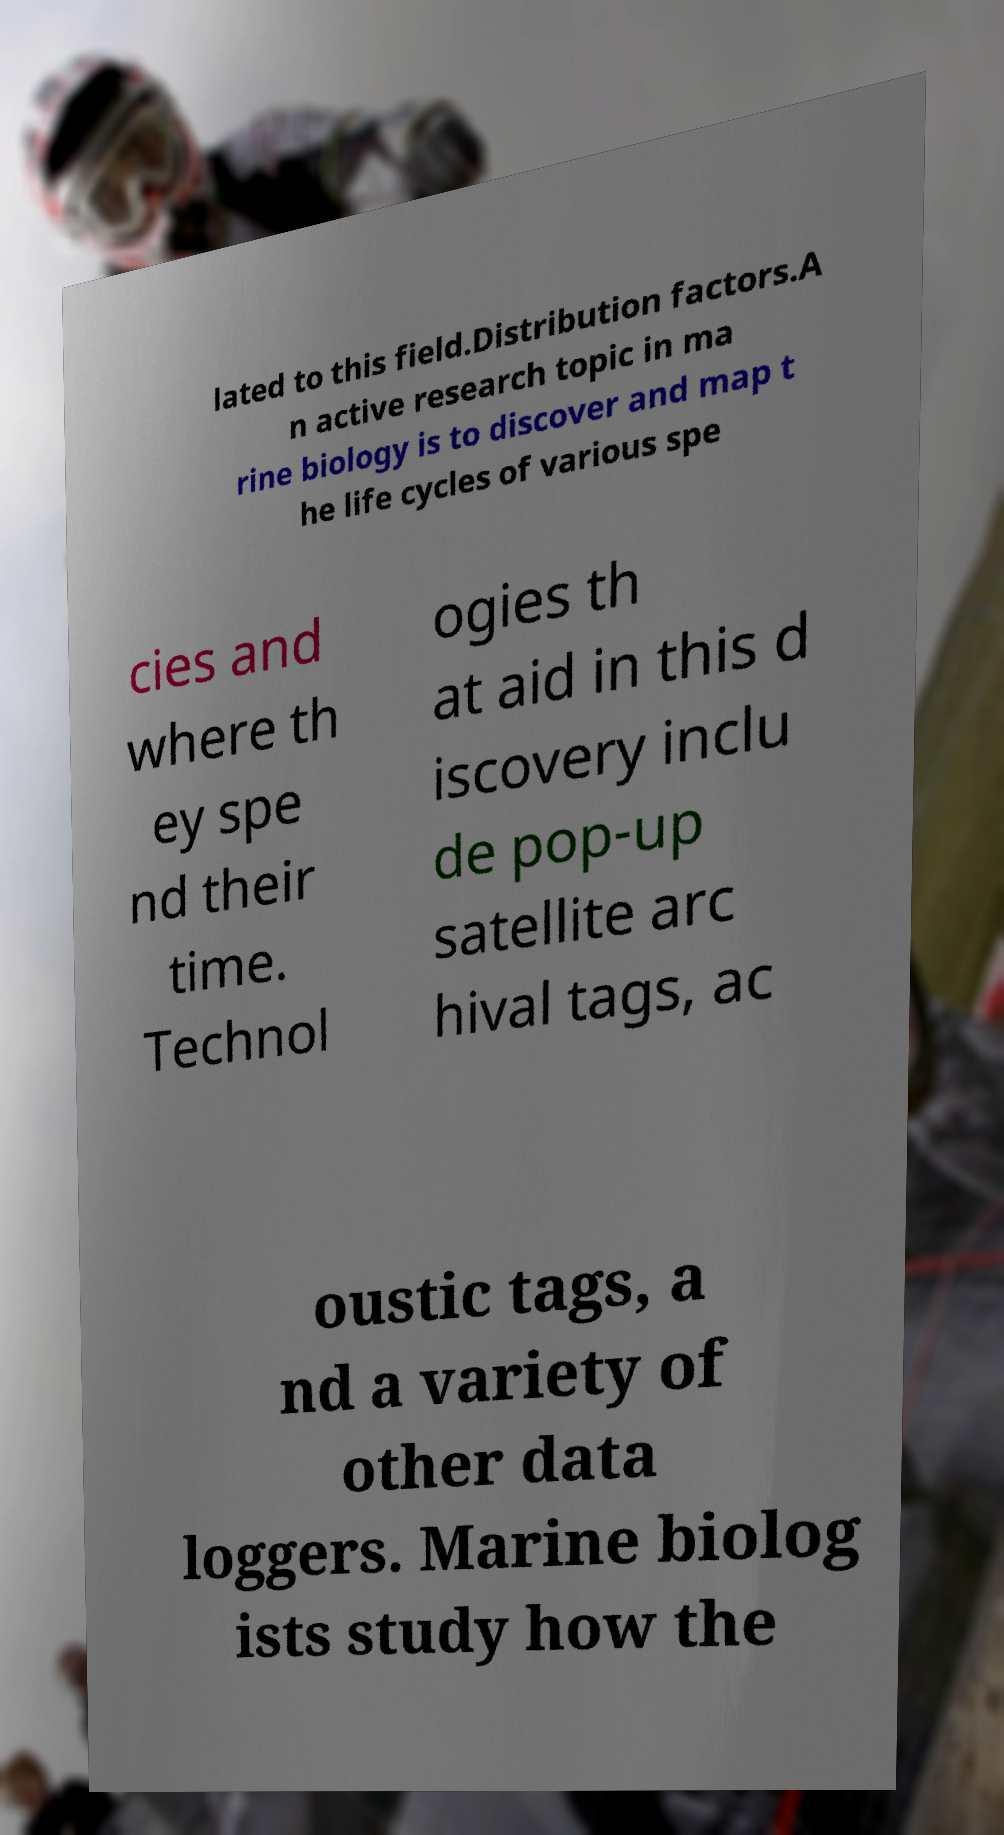Can you read and provide the text displayed in the image?This photo seems to have some interesting text. Can you extract and type it out for me? lated to this field.Distribution factors.A n active research topic in ma rine biology is to discover and map t he life cycles of various spe cies and where th ey spe nd their time. Technol ogies th at aid in this d iscovery inclu de pop-up satellite arc hival tags, ac oustic tags, a nd a variety of other data loggers. Marine biolog ists study how the 